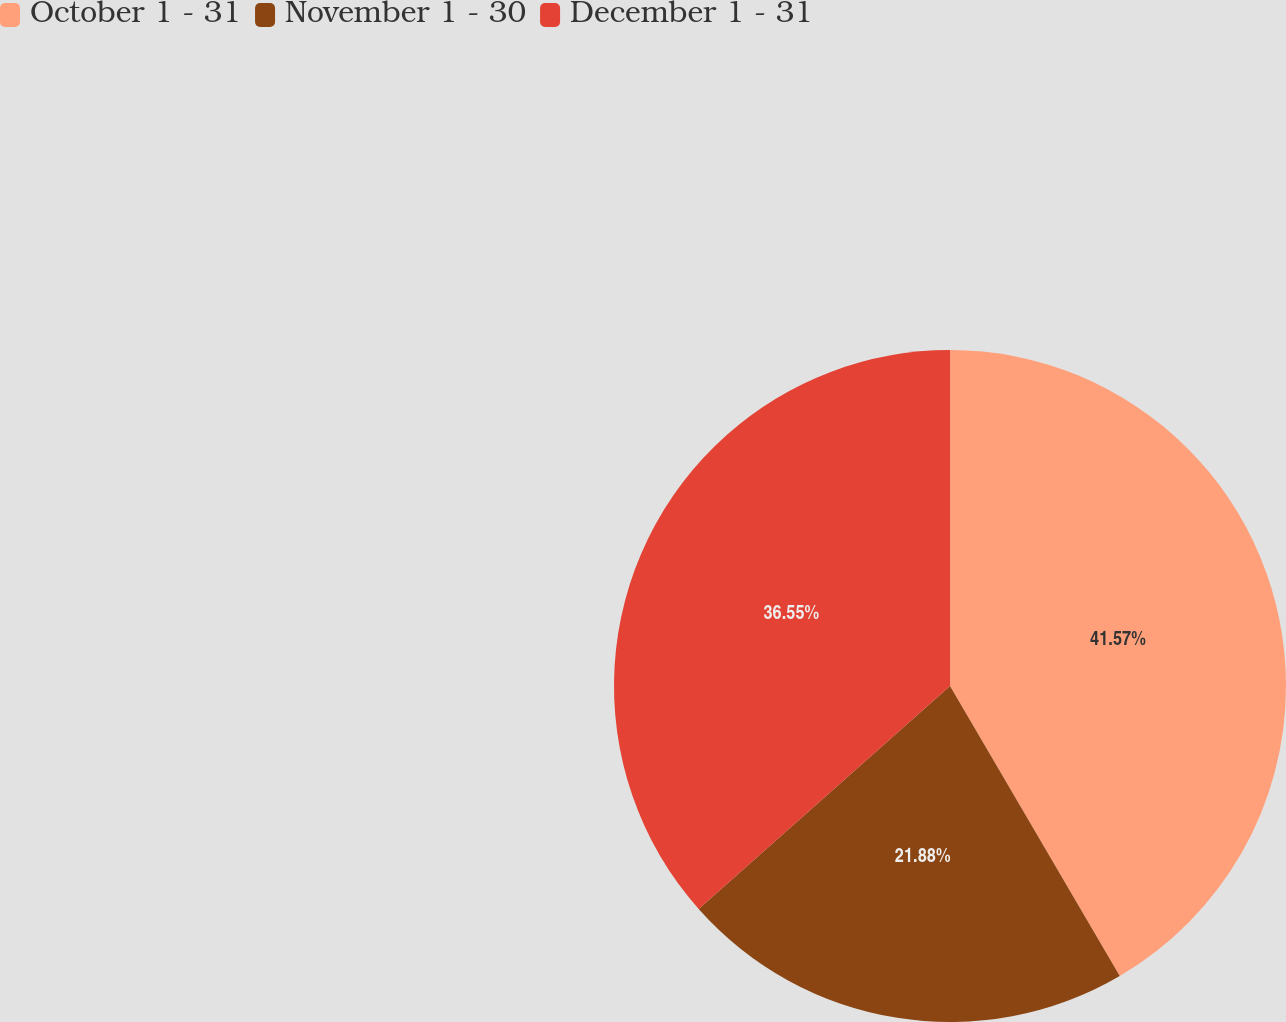Convert chart to OTSL. <chart><loc_0><loc_0><loc_500><loc_500><pie_chart><fcel>October 1 - 31<fcel>November 1 - 30<fcel>December 1 - 31<nl><fcel>41.57%<fcel>21.88%<fcel>36.55%<nl></chart> 